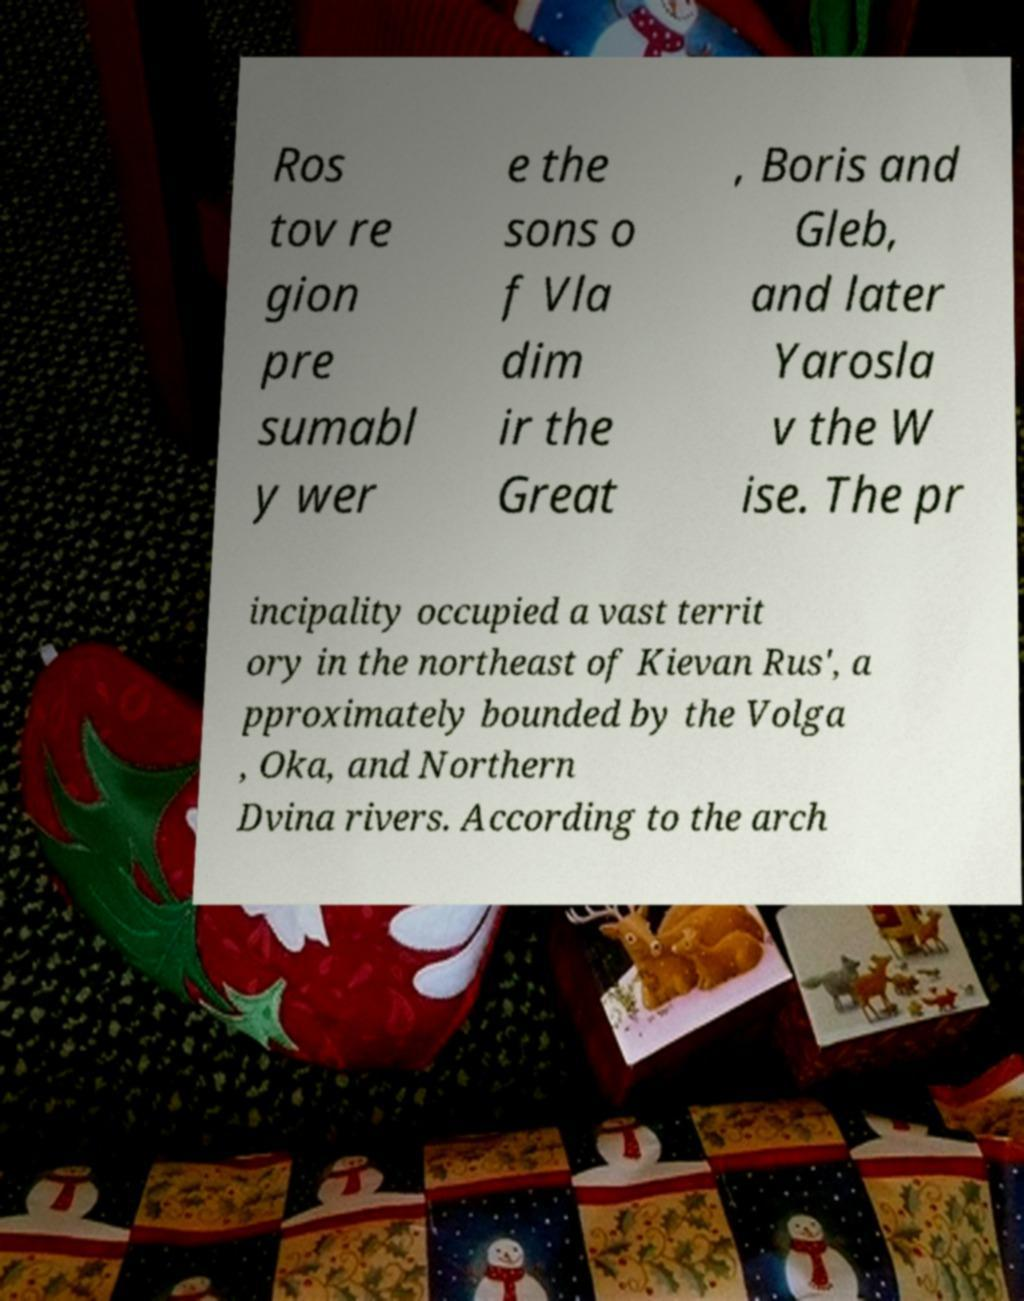Can you accurately transcribe the text from the provided image for me? Ros tov re gion pre sumabl y wer e the sons o f Vla dim ir the Great , Boris and Gleb, and later Yarosla v the W ise. The pr incipality occupied a vast territ ory in the northeast of Kievan Rus', a pproximately bounded by the Volga , Oka, and Northern Dvina rivers. According to the arch 